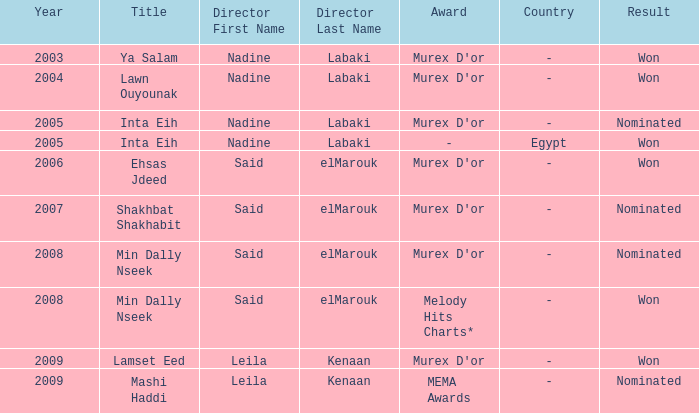Who is the director with the Min Dally Nseek title, and won? Said elMarouk. 